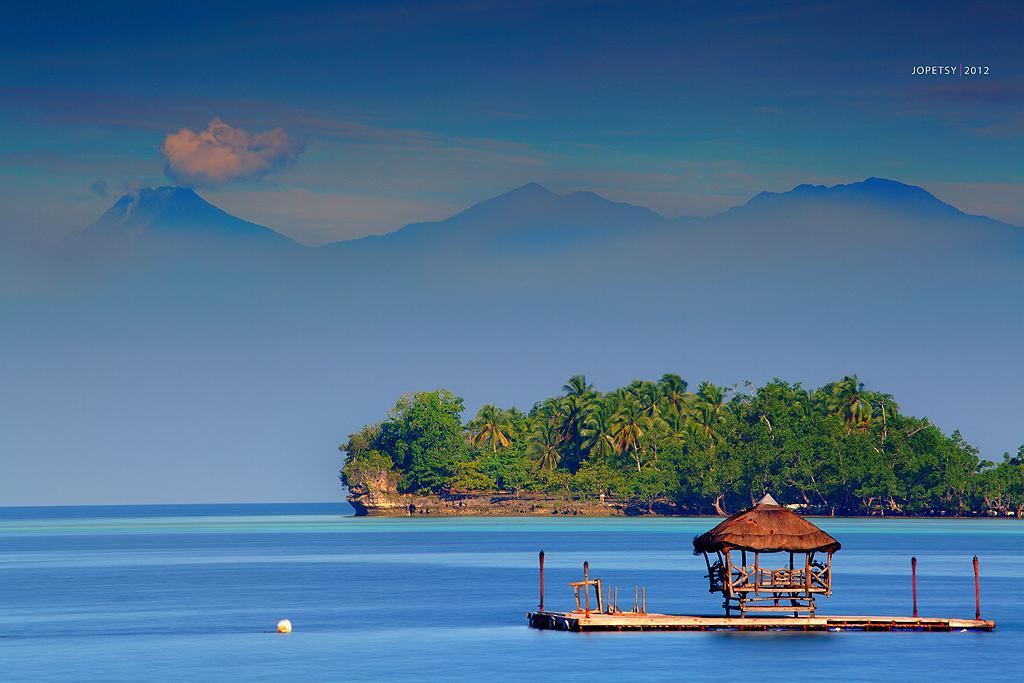What structure is located on the boat in the water? There is a tent house on the boat surface in the water. What type of natural environment can be seen in the image? There are trees and mountains visible in the image. What is visible in the sky in the image? There are clouds in the sky in the image. What type of rice is being cooked on the seashore in the image? There is no rice or seashore present in the image; it features a tent house on a boat in the water with trees, mountains, and clouds visible in the background. 